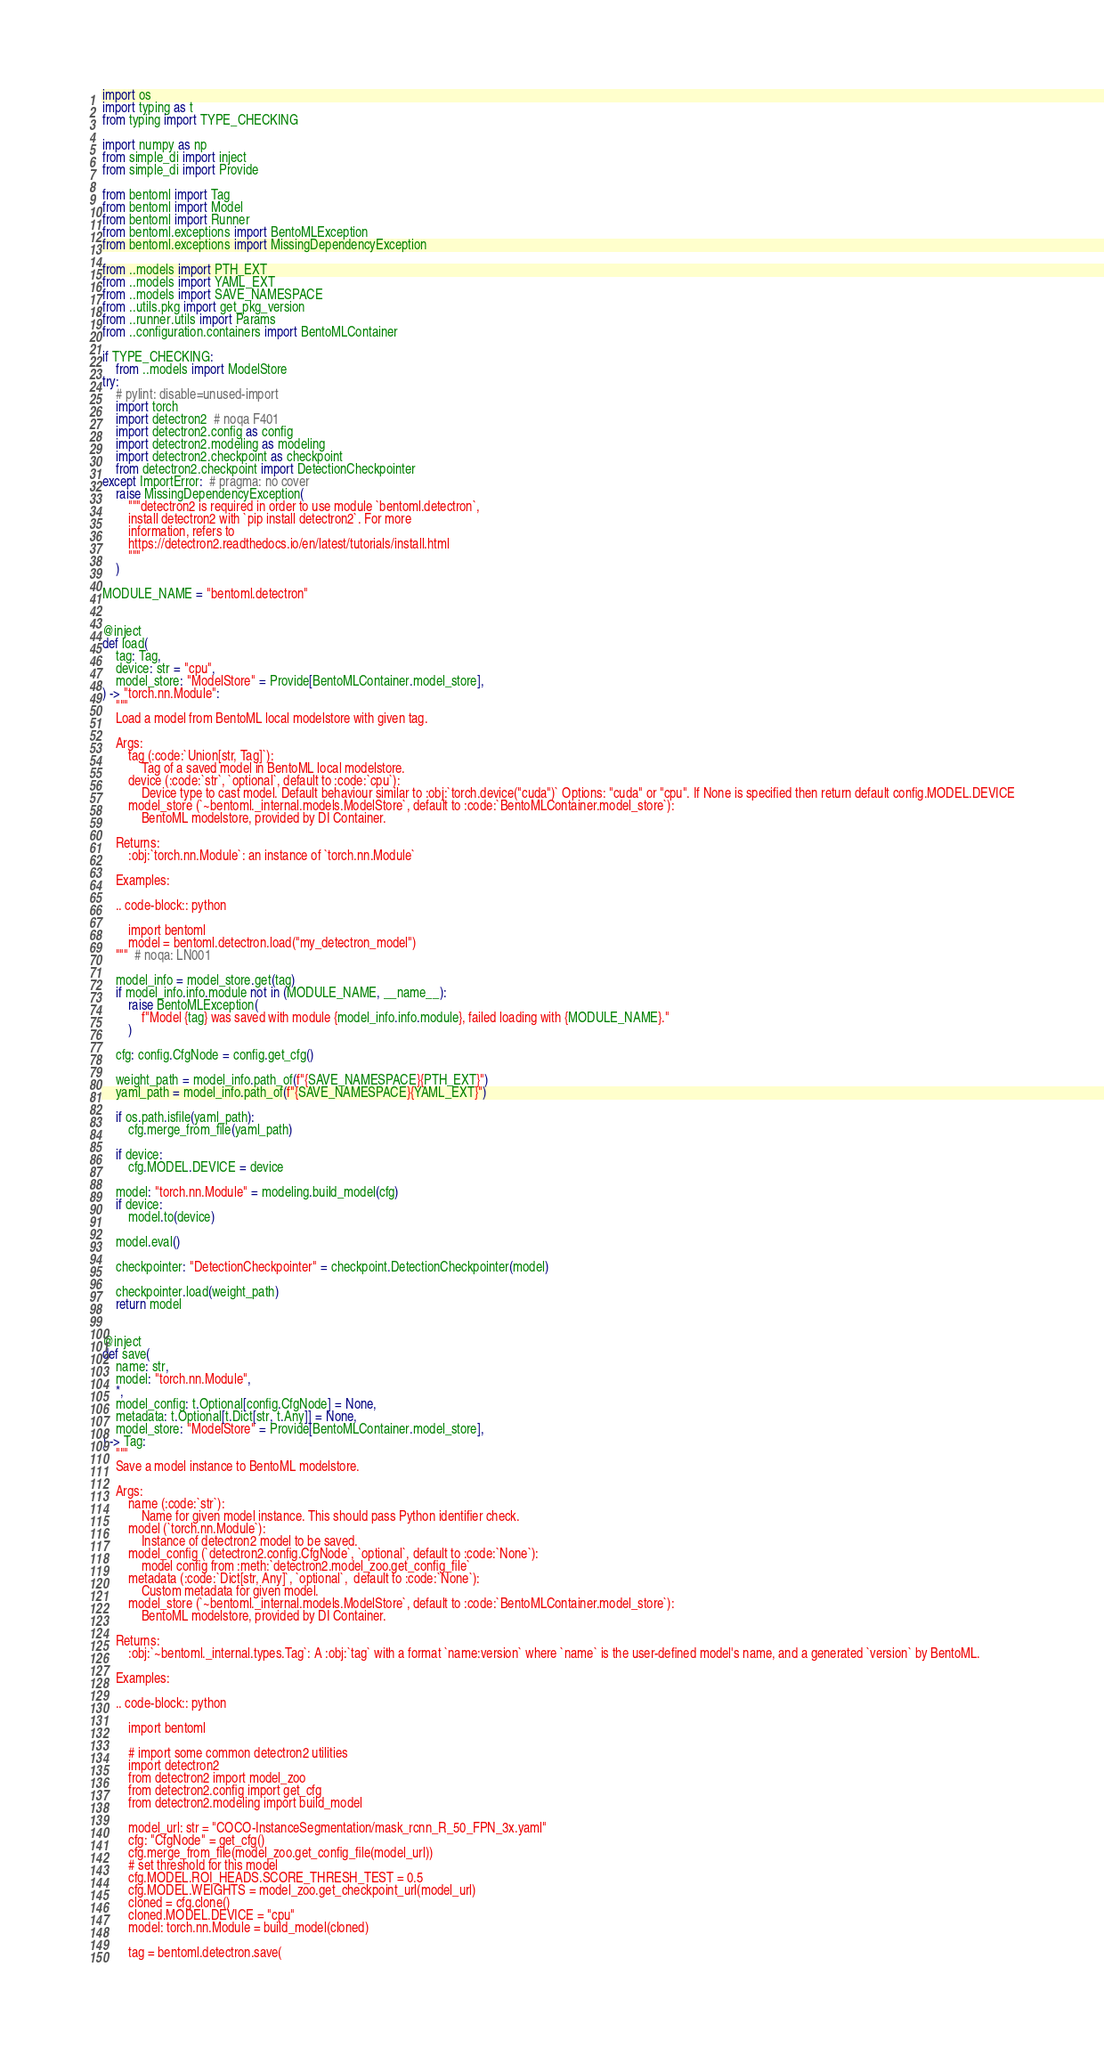<code> <loc_0><loc_0><loc_500><loc_500><_Python_>import os
import typing as t
from typing import TYPE_CHECKING

import numpy as np
from simple_di import inject
from simple_di import Provide

from bentoml import Tag
from bentoml import Model
from bentoml import Runner
from bentoml.exceptions import BentoMLException
from bentoml.exceptions import MissingDependencyException

from ..models import PTH_EXT
from ..models import YAML_EXT
from ..models import SAVE_NAMESPACE
from ..utils.pkg import get_pkg_version
from ..runner.utils import Params
from ..configuration.containers import BentoMLContainer

if TYPE_CHECKING:
    from ..models import ModelStore
try:
    # pylint: disable=unused-import
    import torch
    import detectron2  # noqa F401
    import detectron2.config as config
    import detectron2.modeling as modeling
    import detectron2.checkpoint as checkpoint
    from detectron2.checkpoint import DetectionCheckpointer
except ImportError:  # pragma: no cover
    raise MissingDependencyException(
        """detectron2 is required in order to use module `bentoml.detectron`,
        install detectron2 with `pip install detectron2`. For more
        information, refers to
        https://detectron2.readthedocs.io/en/latest/tutorials/install.html
        """
    )

MODULE_NAME = "bentoml.detectron"


@inject
def load(
    tag: Tag,
    device: str = "cpu",
    model_store: "ModelStore" = Provide[BentoMLContainer.model_store],
) -> "torch.nn.Module":
    """
    Load a model from BentoML local modelstore with given tag.

    Args:
        tag (:code:`Union[str, Tag]`):
            Tag of a saved model in BentoML local modelstore.
        device (:code:`str`, `optional`, default to :code:`cpu`):
            Device type to cast model. Default behaviour similar to :obj:`torch.device("cuda")` Options: "cuda" or "cpu". If None is specified then return default config.MODEL.DEVICE
        model_store (`~bentoml._internal.models.ModelStore`, default to :code:`BentoMLContainer.model_store`):
            BentoML modelstore, provided by DI Container.

    Returns:
        :obj:`torch.nn.Module`: an instance of `torch.nn.Module`

    Examples:

    .. code-block:: python

        import bentoml
        model = bentoml.detectron.load("my_detectron_model")
    """  # noqa: LN001

    model_info = model_store.get(tag)
    if model_info.info.module not in (MODULE_NAME, __name__):
        raise BentoMLException(
            f"Model {tag} was saved with module {model_info.info.module}, failed loading with {MODULE_NAME}."
        )

    cfg: config.CfgNode = config.get_cfg()

    weight_path = model_info.path_of(f"{SAVE_NAMESPACE}{PTH_EXT}")
    yaml_path = model_info.path_of(f"{SAVE_NAMESPACE}{YAML_EXT}")

    if os.path.isfile(yaml_path):
        cfg.merge_from_file(yaml_path)

    if device:
        cfg.MODEL.DEVICE = device

    model: "torch.nn.Module" = modeling.build_model(cfg)
    if device:
        model.to(device)

    model.eval()

    checkpointer: "DetectionCheckpointer" = checkpoint.DetectionCheckpointer(model)

    checkpointer.load(weight_path)
    return model


@inject
def save(
    name: str,
    model: "torch.nn.Module",
    *,
    model_config: t.Optional[config.CfgNode] = None,
    metadata: t.Optional[t.Dict[str, t.Any]] = None,
    model_store: "ModelStore" = Provide[BentoMLContainer.model_store],
) -> Tag:
    """
    Save a model instance to BentoML modelstore.

    Args:
        name (:code:`str`):
            Name for given model instance. This should pass Python identifier check.
        model (`torch.nn.Module`):
            Instance of detectron2 model to be saved.
        model_config (`detectron2.config.CfgNode`, `optional`, default to :code:`None`):
            model config from :meth:`detectron2.model_zoo.get_config_file`
        metadata (:code:`Dict[str, Any]`, `optional`,  default to :code:`None`):
            Custom metadata for given model.
        model_store (`~bentoml._internal.models.ModelStore`, default to :code:`BentoMLContainer.model_store`):
            BentoML modelstore, provided by DI Container.

    Returns:
        :obj:`~bentoml._internal.types.Tag`: A :obj:`tag` with a format `name:version` where `name` is the user-defined model's name, and a generated `version` by BentoML.

    Examples:

    .. code-block:: python

        import bentoml

        # import some common detectron2 utilities
        import detectron2
        from detectron2 import model_zoo
        from detectron2.config import get_cfg
        from detectron2.modeling import build_model

        model_url: str = "COCO-InstanceSegmentation/mask_rcnn_R_50_FPN_3x.yaml"
        cfg: "CfgNode" = get_cfg()
        cfg.merge_from_file(model_zoo.get_config_file(model_url))
        # set threshold for this model
        cfg.MODEL.ROI_HEADS.SCORE_THRESH_TEST = 0.5
        cfg.MODEL.WEIGHTS = model_zoo.get_checkpoint_url(model_url)
        cloned = cfg.clone()
        cloned.MODEL.DEVICE = "cpu"
        model: torch.nn.Module = build_model(cloned)

        tag = bentoml.detectron.save(</code> 